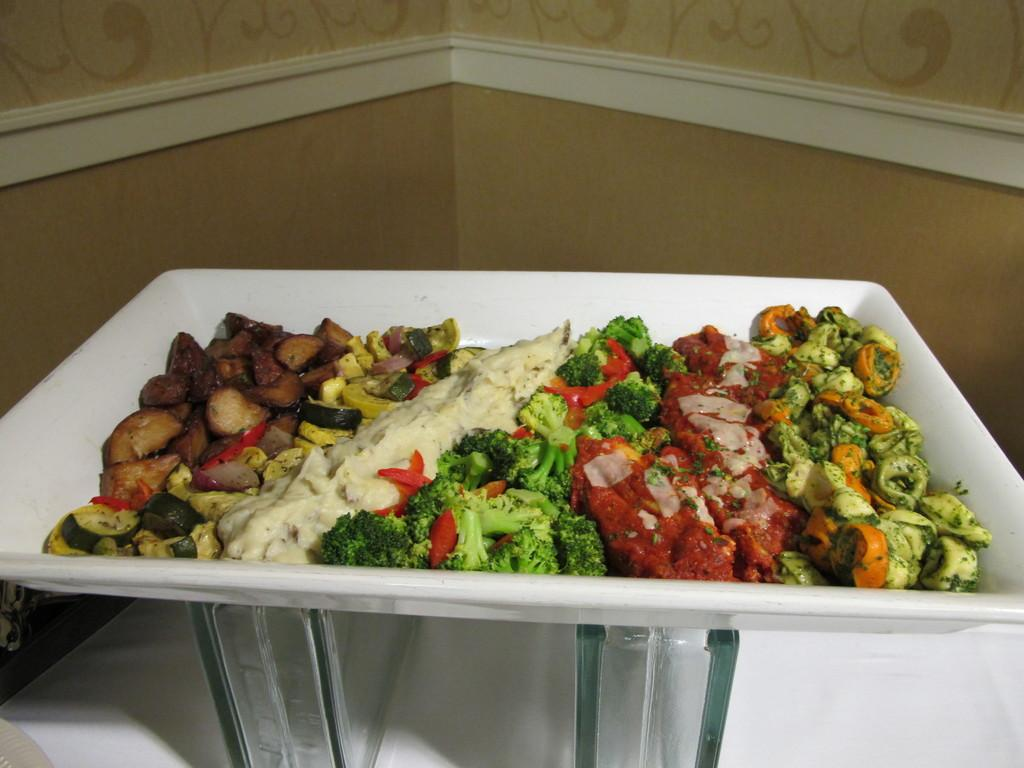What is on the plate that is visible in the image? There is a plate with food in the image. What color is the plate? The plate is white. How is the plate elevated in the image? The plate is on glass stands. Where is the plate located in the image? The plate is on a table. What can be seen in the background of the image? There is a cream-colored wall in the background of the image. What type of plant is growing on the plate in the image? There is no plant growing on the plate in the image; it contains food. What is the name of the person who prepared the food on the plate? The provided facts do not mention the name of the person who prepared the food on the plate. 